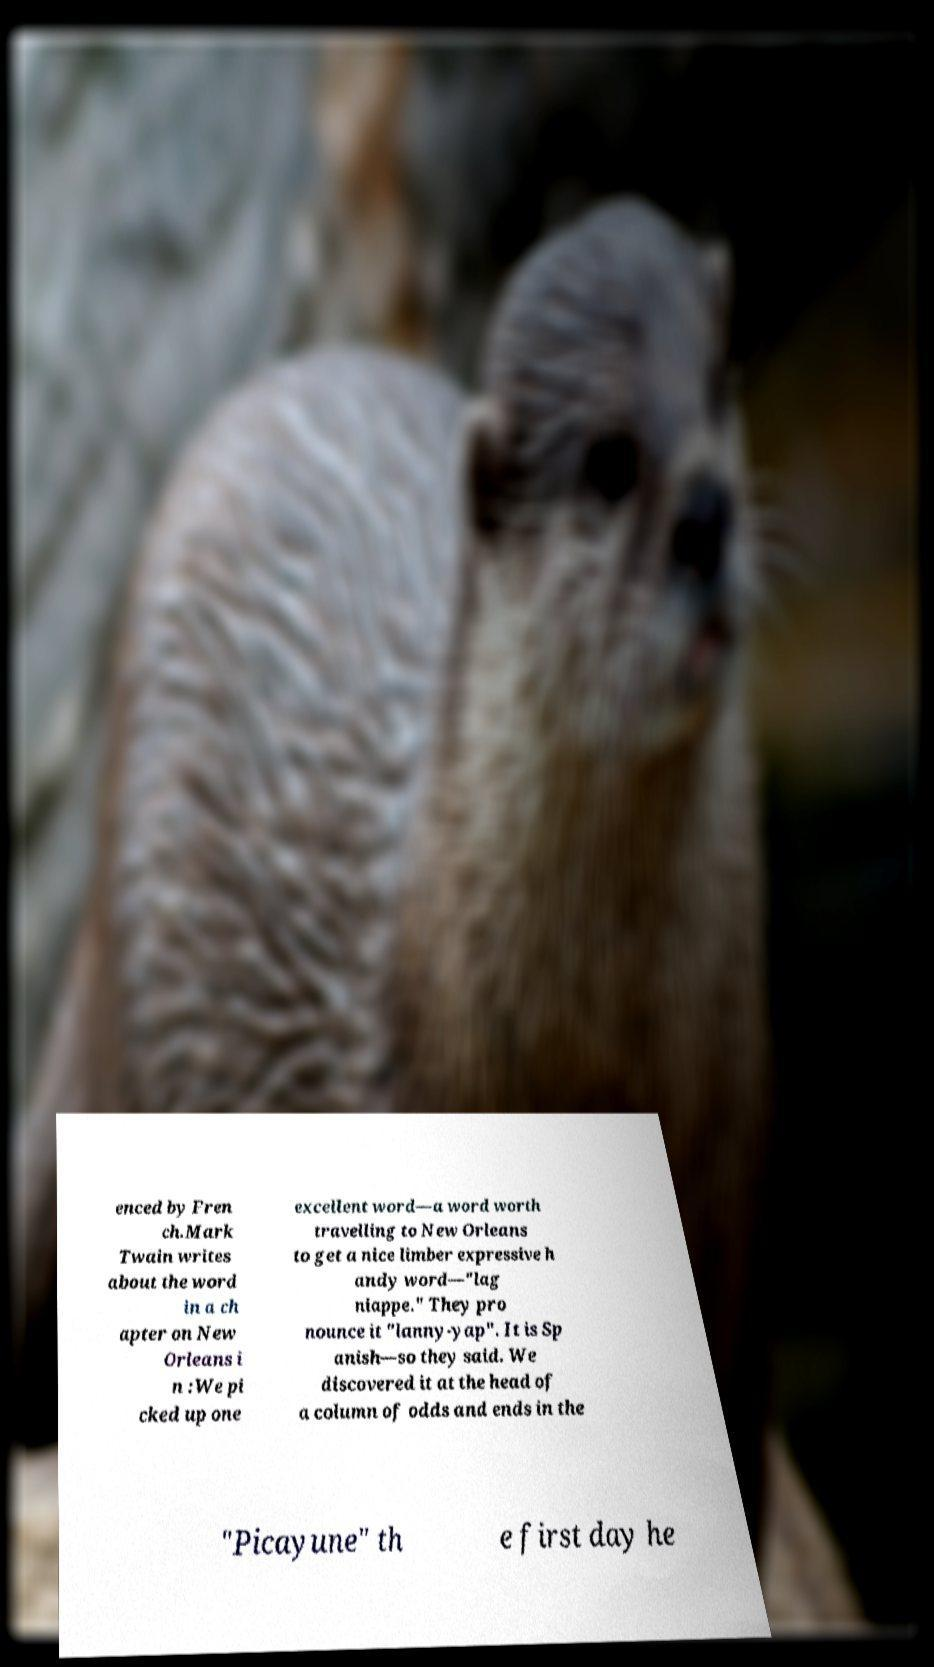Please identify and transcribe the text found in this image. enced by Fren ch.Mark Twain writes about the word in a ch apter on New Orleans i n :We pi cked up one excellent word—a word worth travelling to New Orleans to get a nice limber expressive h andy word—"lag niappe." They pro nounce it "lanny-yap". It is Sp anish—so they said. We discovered it at the head of a column of odds and ends in the "Picayune" th e first day he 